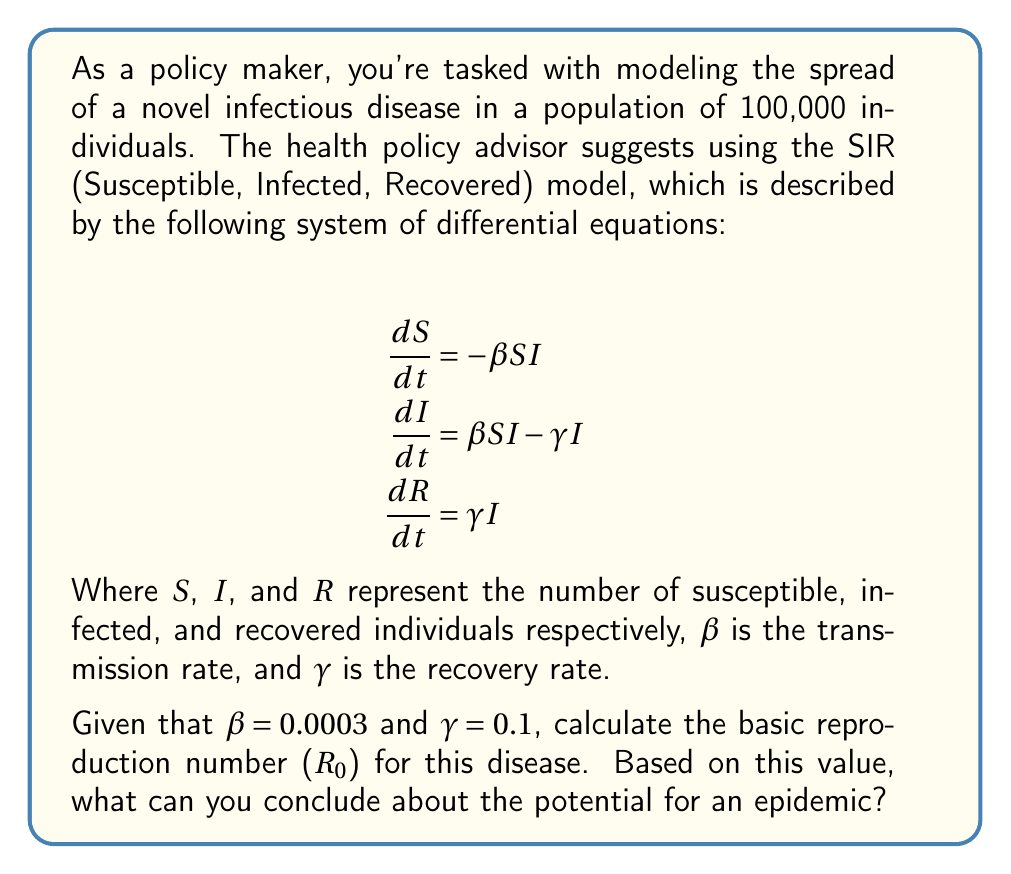Can you solve this math problem? To solve this problem, we'll follow these steps:

1) The basic reproduction number ($R_0$) is a key parameter in epidemiology that represents the average number of secondary infections caused by one infected individual in a completely susceptible population.

2) For the SIR model, $R_0$ is given by the formula:

   $$R_0 = \frac{\beta N}{\gamma}$$

   Where $N$ is the total population size.

3) We are given:
   - $\beta = 0.0003$ (transmission rate)
   - $\gamma = 0.1$ (recovery rate)
   - $N = 100,000$ (total population)

4) Let's substitute these values into the formula:

   $$R_0 = \frac{0.0003 \times 100,000}{0.1}$$

5) Simplifying:

   $$R_0 = \frac{30}{0.1} = 300$$

6) Interpretation:
   - If $R_0 > 1$, the disease can spread and an epidemic is possible.
   - If $R_0 < 1$, the disease will die out.

7) In this case, $R_0 = 300$, which is much greater than 1.

Therefore, we can conclude that there is a high potential for an epidemic, as each infected individual is expected to infect 300 others in a fully susceptible population.
Answer: $R_0 = 300$; high epidemic potential 